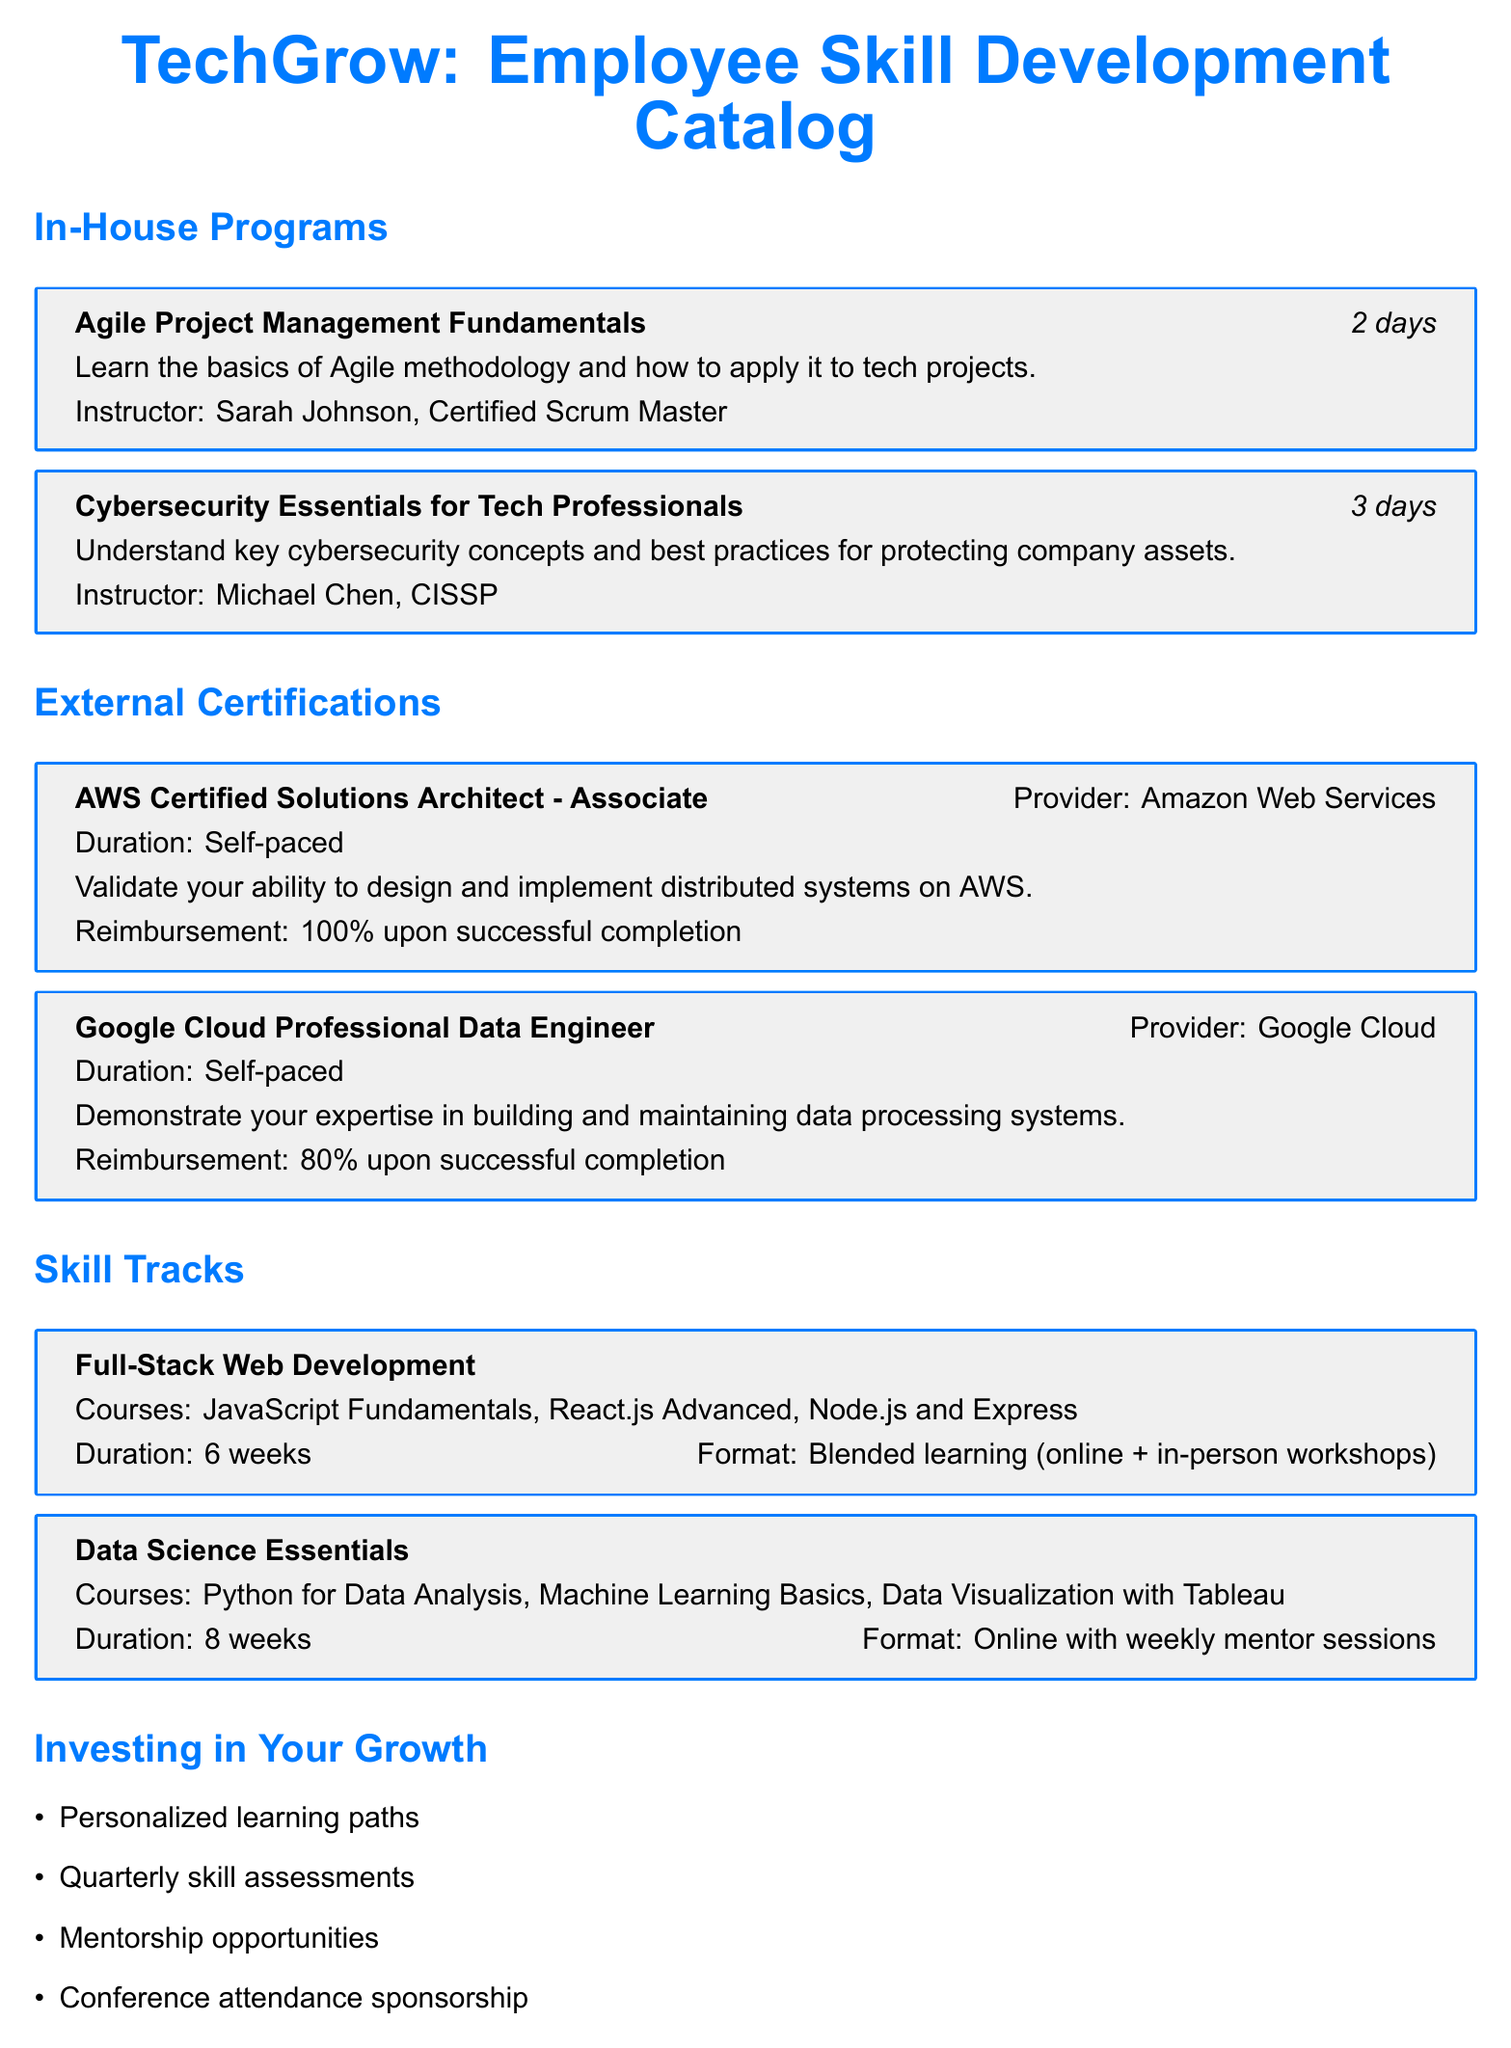What is the first in-house training program listed? The first in-house program is the one that appears at the top of the list under "In-House Programs."
Answer: Agile Project Management Fundamentals Who is the instructor for the Cybersecurity Essentials program? The instructor is mentioned directly under the program details for Cybersecurity Essentials.
Answer: Michael Chen, CISSP What is the duration of the AWS Certified Solutions Architect certification? The duration is specified in the certification details section as self-paced, which implies flexibility in completion time.
Answer: Self-paced How much reimbursement is offered after successful completion of the Google Cloud certification? The reimbursement amount is clearly stated with the corresponding certification details.
Answer: 80% upon successful completion What is the format of the Full-Stack Web Development skill track? The format is specified within the details of the skill track, showing how the learning will be delivered.
Answer: Blended learning (online + in-person workshops) How many weeks does the Data Science Essentials skill track take? The number of weeks is outlined in the details of the Data Science Essentials track.
Answer: 8 weeks Who is the Learning & Development Manager? The contact information clearly states the name of the person responsible for learning and development inquiries.
Answer: Emily Rodriguez What kind of personalized support is mentioned in the investing section? The investing section lists various forms of support for employee growth, one of which specifies individualized approaches.
Answer: Personalized learning paths 